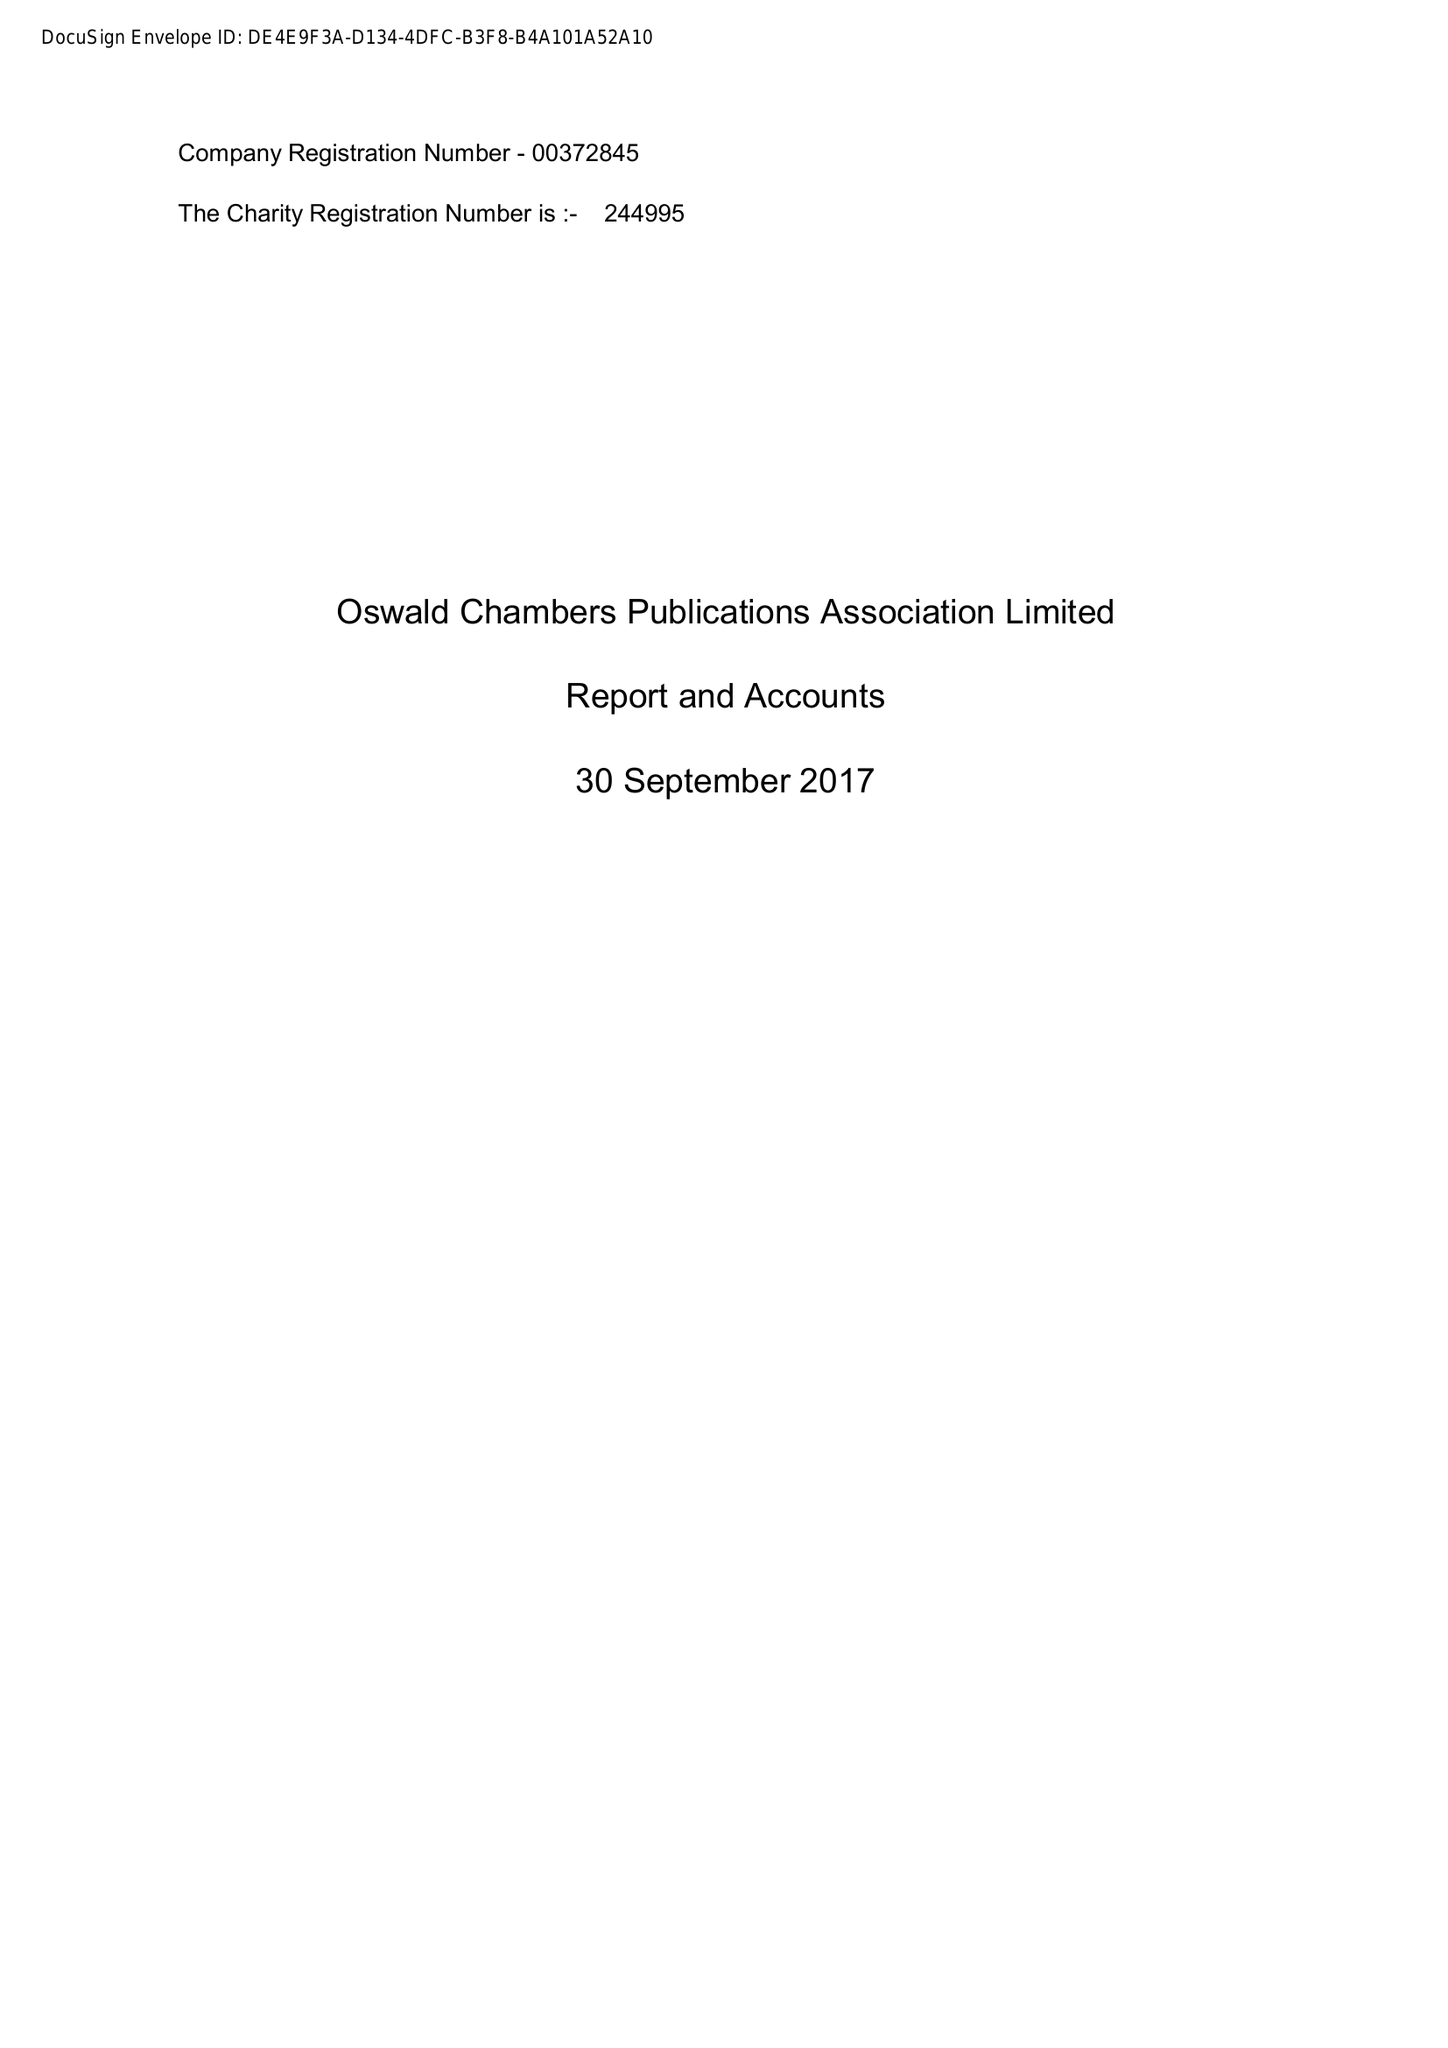What is the value for the spending_annually_in_british_pounds?
Answer the question using a single word or phrase. 62985.00 